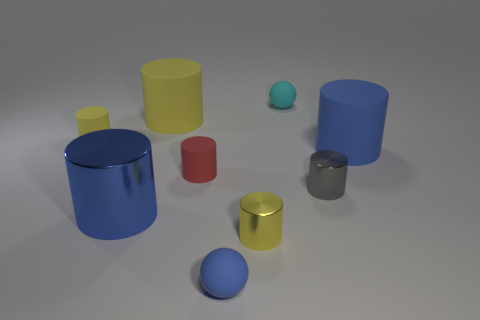How many objects are either small balls or blue cylinders behind the red matte thing?
Offer a terse response. 3. What material is the small gray object that is the same shape as the small yellow shiny object?
Make the answer very short. Metal. There is a yellow rubber thing that is behind the small yellow matte thing; is it the same shape as the red matte object?
Your answer should be compact. Yes. Is there anything else that has the same size as the red rubber cylinder?
Your answer should be compact. Yes. Are there fewer yellow metal objects that are behind the gray shiny thing than large blue things to the left of the red cylinder?
Your answer should be very brief. Yes. What number of other objects are there of the same shape as the yellow metal object?
Your response must be concise. 6. There is a blue matte thing behind the ball that is in front of the yellow thing on the left side of the blue metal thing; what size is it?
Provide a short and direct response. Large. How many gray objects are either big objects or matte cylinders?
Your answer should be compact. 0. The large thing that is behind the yellow cylinder that is to the left of the large yellow object is what shape?
Your response must be concise. Cylinder. Is the size of the blue object that is in front of the big blue metal cylinder the same as the gray metallic object in front of the tiny red matte thing?
Your response must be concise. Yes. 